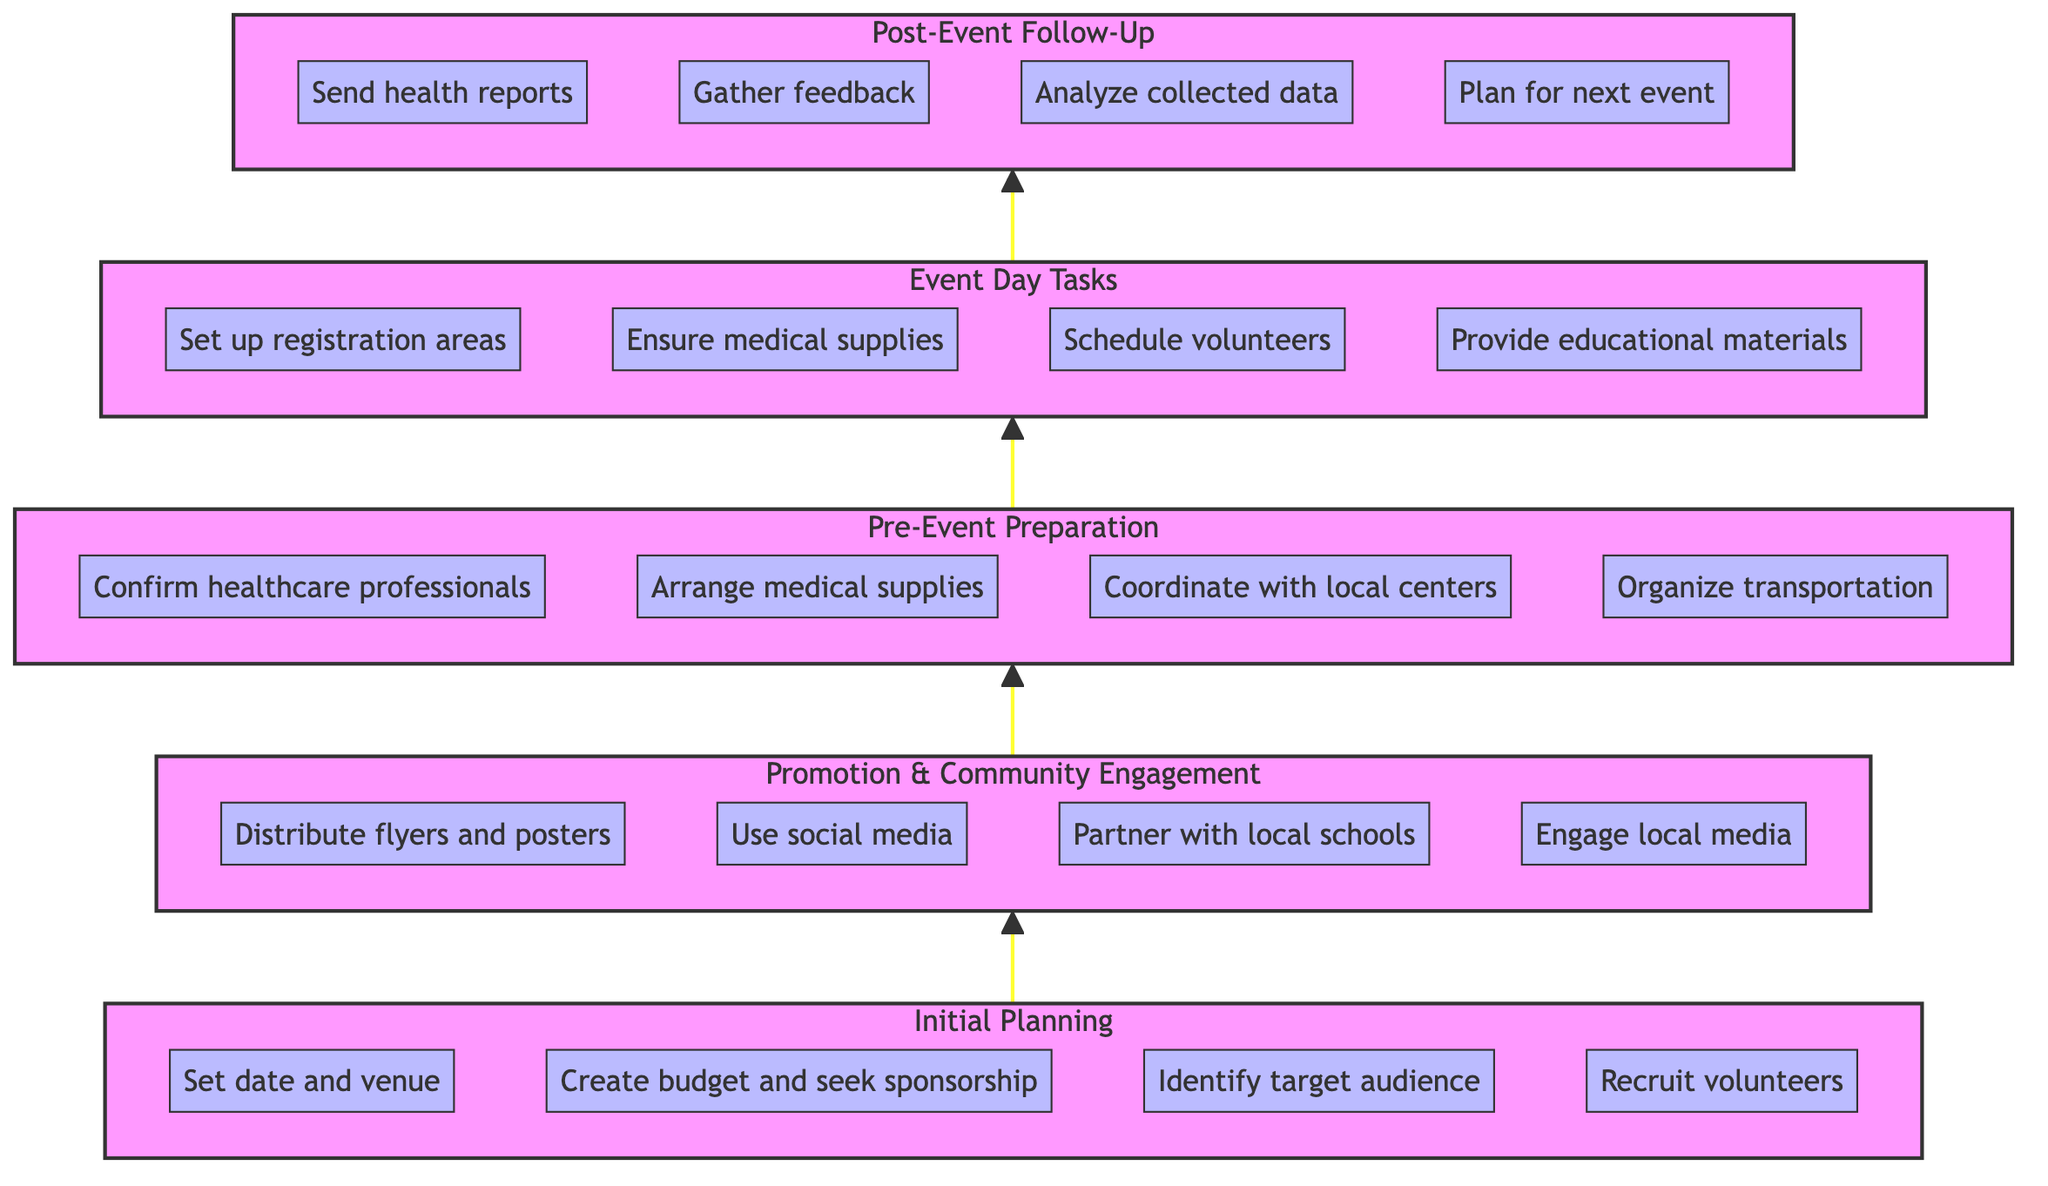What is the topmost node in the diagram? The topmost node is the "Post-Event Follow-Up" which signifies the final stage of the health check-up event.
Answer: Post-Event Follow-Up How many main phases are there in the flowchart? The diagram has five main phases: Initial Planning, Promotion & Community Engagement, Pre-Event Preparation, Event Day Tasks, and Post-Event Follow-Up.
Answer: Five What is the connection between the "Pre-Event Preparation" and "Event Day Tasks"? The "Pre-Event Preparation" phase flows directly into the "Event Day Tasks" phase, indicating that preparations lead to what should be done on the event day.
Answer: Direct connection Which phase involves engaging local media? Engaging local media is part of the "Promotion & Community Engagement" phase, aimed at spreading awareness about the event.
Answer: Promotion & Community Engagement List one task that occurs during the "Event Day Tasks". One task during the "Event Day Tasks" phase is to "Set up registration and waiting areas" which helps manage participants on the event day.
Answer: Set up registration and waiting areas What do you do after the "Event Day Tasks"? After completing the "Event Day Tasks," the next phase is "Post-Event Follow-Up," which focuses on actions like sending health reports to participants.
Answer: Post-Event Follow-Up How are the phases arranged in the diagram from bottom to top? The phases are arranged sequentially starting from "Initial Planning" at the bottom to "Post-Event Follow-Up" at the top, illustrating the flow of organization tasks.
Answer: Sequential from Initial Planning to Post-Event Follow-Up What is the last task mentioned in the "Post-Event Follow-Up" phase? The last task mentioned in the "Post-Event Follow-Up" phase is "Plan for the next event based on insights," which signifies future planning based on feedback and data analysis.
Answer: Plan for the next event based on insights 